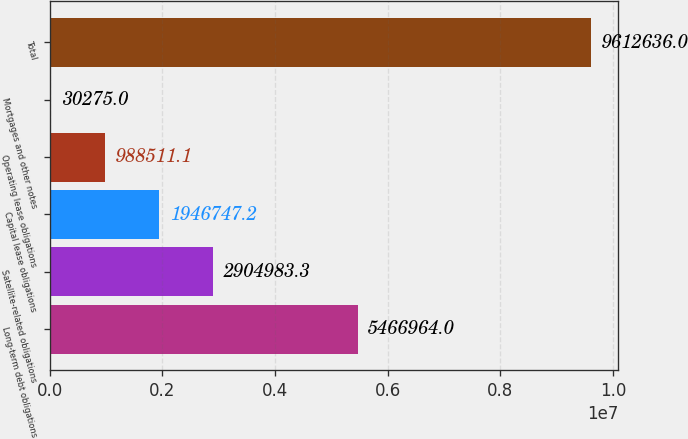<chart> <loc_0><loc_0><loc_500><loc_500><bar_chart><fcel>Long-term debt obligations<fcel>Satellite-related obligations<fcel>Capital lease obligations<fcel>Operating lease obligations<fcel>Mortgages and other notes<fcel>Total<nl><fcel>5.46696e+06<fcel>2.90498e+06<fcel>1.94675e+06<fcel>988511<fcel>30275<fcel>9.61264e+06<nl></chart> 